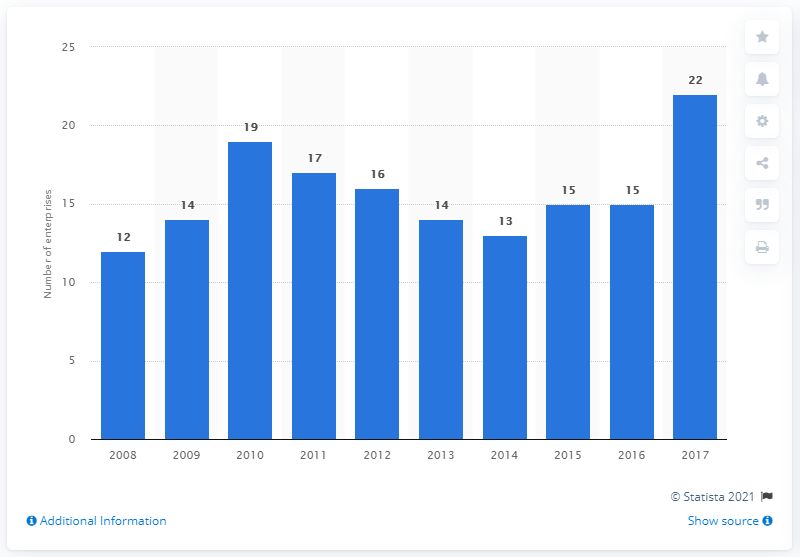Point out several critical features in this image. In 2017, there were approximately 22 enterprises operating in Denmark's manufacturing sector. 